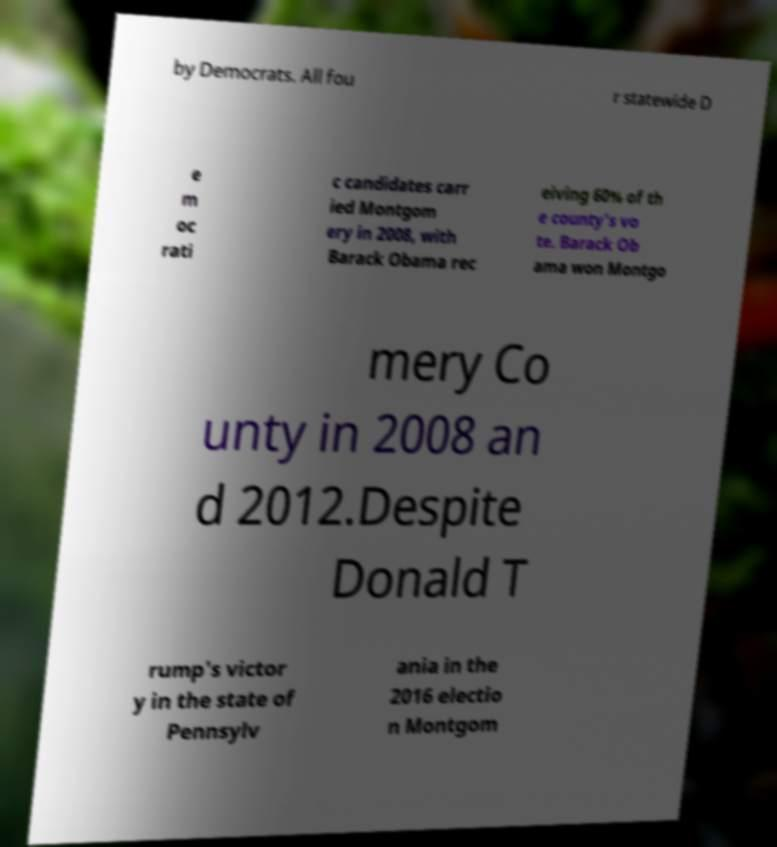Can you read and provide the text displayed in the image?This photo seems to have some interesting text. Can you extract and type it out for me? by Democrats. All fou r statewide D e m oc rati c candidates carr ied Montgom ery in 2008, with Barack Obama rec eiving 60% of th e county's vo te. Barack Ob ama won Montgo mery Co unty in 2008 an d 2012.Despite Donald T rump's victor y in the state of Pennsylv ania in the 2016 electio n Montgom 